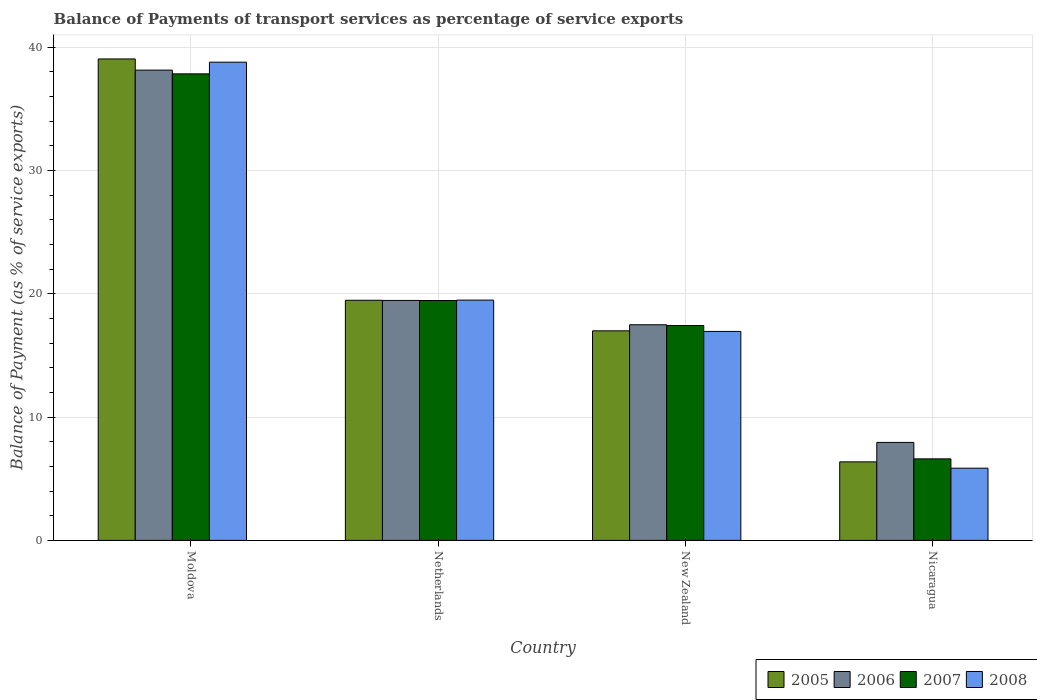How many groups of bars are there?
Your answer should be very brief. 4. Are the number of bars per tick equal to the number of legend labels?
Offer a very short reply. Yes. Are the number of bars on each tick of the X-axis equal?
Your answer should be compact. Yes. How many bars are there on the 4th tick from the left?
Offer a terse response. 4. What is the label of the 1st group of bars from the left?
Provide a short and direct response. Moldova. In how many cases, is the number of bars for a given country not equal to the number of legend labels?
Your answer should be very brief. 0. What is the balance of payments of transport services in 2008 in New Zealand?
Offer a terse response. 16.94. Across all countries, what is the maximum balance of payments of transport services in 2006?
Offer a very short reply. 38.13. Across all countries, what is the minimum balance of payments of transport services in 2008?
Make the answer very short. 5.85. In which country was the balance of payments of transport services in 2008 maximum?
Your answer should be compact. Moldova. In which country was the balance of payments of transport services in 2007 minimum?
Give a very brief answer. Nicaragua. What is the total balance of payments of transport services in 2007 in the graph?
Offer a terse response. 81.31. What is the difference between the balance of payments of transport services in 2006 in Moldova and that in Nicaragua?
Your answer should be compact. 30.19. What is the difference between the balance of payments of transport services in 2005 in New Zealand and the balance of payments of transport services in 2008 in Moldova?
Your answer should be compact. -21.78. What is the average balance of payments of transport services in 2007 per country?
Your answer should be compact. 20.33. What is the difference between the balance of payments of transport services of/in 2008 and balance of payments of transport services of/in 2006 in Nicaragua?
Provide a succinct answer. -2.09. In how many countries, is the balance of payments of transport services in 2005 greater than 20 %?
Offer a terse response. 1. What is the ratio of the balance of payments of transport services in 2006 in Netherlands to that in Nicaragua?
Provide a short and direct response. 2.45. Is the balance of payments of transport services in 2005 in Netherlands less than that in New Zealand?
Provide a short and direct response. No. Is the difference between the balance of payments of transport services in 2008 in Netherlands and New Zealand greater than the difference between the balance of payments of transport services in 2006 in Netherlands and New Zealand?
Offer a terse response. Yes. What is the difference between the highest and the second highest balance of payments of transport services in 2006?
Offer a very short reply. -1.97. What is the difference between the highest and the lowest balance of payments of transport services in 2008?
Keep it short and to the point. 32.92. In how many countries, is the balance of payments of transport services in 2007 greater than the average balance of payments of transport services in 2007 taken over all countries?
Your response must be concise. 1. Is it the case that in every country, the sum of the balance of payments of transport services in 2007 and balance of payments of transport services in 2005 is greater than the sum of balance of payments of transport services in 2006 and balance of payments of transport services in 2008?
Give a very brief answer. No. What does the 4th bar from the left in Netherlands represents?
Offer a very short reply. 2008. Is it the case that in every country, the sum of the balance of payments of transport services in 2008 and balance of payments of transport services in 2006 is greater than the balance of payments of transport services in 2007?
Give a very brief answer. Yes. How many countries are there in the graph?
Ensure brevity in your answer.  4. Are the values on the major ticks of Y-axis written in scientific E-notation?
Make the answer very short. No. Does the graph contain any zero values?
Ensure brevity in your answer.  No. How many legend labels are there?
Your answer should be compact. 4. How are the legend labels stacked?
Make the answer very short. Horizontal. What is the title of the graph?
Provide a short and direct response. Balance of Payments of transport services as percentage of service exports. Does "2001" appear as one of the legend labels in the graph?
Your answer should be compact. No. What is the label or title of the Y-axis?
Make the answer very short. Balance of Payment (as % of service exports). What is the Balance of Payment (as % of service exports) of 2005 in Moldova?
Offer a very short reply. 39.04. What is the Balance of Payment (as % of service exports) of 2006 in Moldova?
Give a very brief answer. 38.13. What is the Balance of Payment (as % of service exports) in 2007 in Moldova?
Offer a very short reply. 37.83. What is the Balance of Payment (as % of service exports) in 2008 in Moldova?
Keep it short and to the point. 38.78. What is the Balance of Payment (as % of service exports) of 2005 in Netherlands?
Your answer should be compact. 19.47. What is the Balance of Payment (as % of service exports) in 2006 in Netherlands?
Your answer should be compact. 19.46. What is the Balance of Payment (as % of service exports) in 2007 in Netherlands?
Provide a succinct answer. 19.45. What is the Balance of Payment (as % of service exports) in 2008 in Netherlands?
Keep it short and to the point. 19.48. What is the Balance of Payment (as % of service exports) of 2005 in New Zealand?
Provide a succinct answer. 16.99. What is the Balance of Payment (as % of service exports) in 2006 in New Zealand?
Make the answer very short. 17.48. What is the Balance of Payment (as % of service exports) in 2007 in New Zealand?
Offer a terse response. 17.42. What is the Balance of Payment (as % of service exports) of 2008 in New Zealand?
Make the answer very short. 16.94. What is the Balance of Payment (as % of service exports) in 2005 in Nicaragua?
Provide a short and direct response. 6.37. What is the Balance of Payment (as % of service exports) of 2006 in Nicaragua?
Your answer should be very brief. 7.95. What is the Balance of Payment (as % of service exports) in 2007 in Nicaragua?
Give a very brief answer. 6.61. What is the Balance of Payment (as % of service exports) of 2008 in Nicaragua?
Your answer should be very brief. 5.85. Across all countries, what is the maximum Balance of Payment (as % of service exports) of 2005?
Keep it short and to the point. 39.04. Across all countries, what is the maximum Balance of Payment (as % of service exports) of 2006?
Provide a succinct answer. 38.13. Across all countries, what is the maximum Balance of Payment (as % of service exports) of 2007?
Your answer should be very brief. 37.83. Across all countries, what is the maximum Balance of Payment (as % of service exports) of 2008?
Your answer should be very brief. 38.78. Across all countries, what is the minimum Balance of Payment (as % of service exports) of 2005?
Give a very brief answer. 6.37. Across all countries, what is the minimum Balance of Payment (as % of service exports) in 2006?
Provide a succinct answer. 7.95. Across all countries, what is the minimum Balance of Payment (as % of service exports) in 2007?
Provide a short and direct response. 6.61. Across all countries, what is the minimum Balance of Payment (as % of service exports) of 2008?
Keep it short and to the point. 5.85. What is the total Balance of Payment (as % of service exports) of 2005 in the graph?
Provide a succinct answer. 81.87. What is the total Balance of Payment (as % of service exports) in 2006 in the graph?
Give a very brief answer. 83.02. What is the total Balance of Payment (as % of service exports) of 2007 in the graph?
Your answer should be compact. 81.31. What is the total Balance of Payment (as % of service exports) in 2008 in the graph?
Give a very brief answer. 81.06. What is the difference between the Balance of Payment (as % of service exports) in 2005 in Moldova and that in Netherlands?
Offer a terse response. 19.57. What is the difference between the Balance of Payment (as % of service exports) of 2006 in Moldova and that in Netherlands?
Your answer should be compact. 18.67. What is the difference between the Balance of Payment (as % of service exports) in 2007 in Moldova and that in Netherlands?
Your response must be concise. 18.38. What is the difference between the Balance of Payment (as % of service exports) in 2008 in Moldova and that in Netherlands?
Offer a very short reply. 19.29. What is the difference between the Balance of Payment (as % of service exports) in 2005 in Moldova and that in New Zealand?
Your answer should be very brief. 22.05. What is the difference between the Balance of Payment (as % of service exports) in 2006 in Moldova and that in New Zealand?
Offer a very short reply. 20.65. What is the difference between the Balance of Payment (as % of service exports) of 2007 in Moldova and that in New Zealand?
Offer a terse response. 20.41. What is the difference between the Balance of Payment (as % of service exports) of 2008 in Moldova and that in New Zealand?
Your response must be concise. 21.83. What is the difference between the Balance of Payment (as % of service exports) of 2005 in Moldova and that in Nicaragua?
Make the answer very short. 32.67. What is the difference between the Balance of Payment (as % of service exports) of 2006 in Moldova and that in Nicaragua?
Your response must be concise. 30.19. What is the difference between the Balance of Payment (as % of service exports) of 2007 in Moldova and that in Nicaragua?
Provide a short and direct response. 31.22. What is the difference between the Balance of Payment (as % of service exports) of 2008 in Moldova and that in Nicaragua?
Provide a short and direct response. 32.92. What is the difference between the Balance of Payment (as % of service exports) of 2005 in Netherlands and that in New Zealand?
Keep it short and to the point. 2.48. What is the difference between the Balance of Payment (as % of service exports) of 2006 in Netherlands and that in New Zealand?
Keep it short and to the point. 1.97. What is the difference between the Balance of Payment (as % of service exports) of 2007 in Netherlands and that in New Zealand?
Offer a terse response. 2.03. What is the difference between the Balance of Payment (as % of service exports) in 2008 in Netherlands and that in New Zealand?
Make the answer very short. 2.54. What is the difference between the Balance of Payment (as % of service exports) in 2005 in Netherlands and that in Nicaragua?
Offer a very short reply. 13.1. What is the difference between the Balance of Payment (as % of service exports) of 2006 in Netherlands and that in Nicaragua?
Keep it short and to the point. 11.51. What is the difference between the Balance of Payment (as % of service exports) of 2007 in Netherlands and that in Nicaragua?
Offer a terse response. 12.84. What is the difference between the Balance of Payment (as % of service exports) of 2008 in Netherlands and that in Nicaragua?
Your response must be concise. 13.63. What is the difference between the Balance of Payment (as % of service exports) of 2005 in New Zealand and that in Nicaragua?
Your answer should be compact. 10.62. What is the difference between the Balance of Payment (as % of service exports) of 2006 in New Zealand and that in Nicaragua?
Make the answer very short. 9.54. What is the difference between the Balance of Payment (as % of service exports) of 2007 in New Zealand and that in Nicaragua?
Offer a terse response. 10.81. What is the difference between the Balance of Payment (as % of service exports) in 2008 in New Zealand and that in Nicaragua?
Offer a very short reply. 11.09. What is the difference between the Balance of Payment (as % of service exports) in 2005 in Moldova and the Balance of Payment (as % of service exports) in 2006 in Netherlands?
Give a very brief answer. 19.58. What is the difference between the Balance of Payment (as % of service exports) of 2005 in Moldova and the Balance of Payment (as % of service exports) of 2007 in Netherlands?
Provide a succinct answer. 19.59. What is the difference between the Balance of Payment (as % of service exports) of 2005 in Moldova and the Balance of Payment (as % of service exports) of 2008 in Netherlands?
Provide a short and direct response. 19.56. What is the difference between the Balance of Payment (as % of service exports) in 2006 in Moldova and the Balance of Payment (as % of service exports) in 2007 in Netherlands?
Your answer should be compact. 18.68. What is the difference between the Balance of Payment (as % of service exports) of 2006 in Moldova and the Balance of Payment (as % of service exports) of 2008 in Netherlands?
Keep it short and to the point. 18.65. What is the difference between the Balance of Payment (as % of service exports) of 2007 in Moldova and the Balance of Payment (as % of service exports) of 2008 in Netherlands?
Offer a terse response. 18.35. What is the difference between the Balance of Payment (as % of service exports) in 2005 in Moldova and the Balance of Payment (as % of service exports) in 2006 in New Zealand?
Your answer should be compact. 21.55. What is the difference between the Balance of Payment (as % of service exports) in 2005 in Moldova and the Balance of Payment (as % of service exports) in 2007 in New Zealand?
Your answer should be compact. 21.62. What is the difference between the Balance of Payment (as % of service exports) of 2005 in Moldova and the Balance of Payment (as % of service exports) of 2008 in New Zealand?
Your answer should be very brief. 22.09. What is the difference between the Balance of Payment (as % of service exports) of 2006 in Moldova and the Balance of Payment (as % of service exports) of 2007 in New Zealand?
Offer a very short reply. 20.71. What is the difference between the Balance of Payment (as % of service exports) of 2006 in Moldova and the Balance of Payment (as % of service exports) of 2008 in New Zealand?
Give a very brief answer. 21.19. What is the difference between the Balance of Payment (as % of service exports) of 2007 in Moldova and the Balance of Payment (as % of service exports) of 2008 in New Zealand?
Your response must be concise. 20.89. What is the difference between the Balance of Payment (as % of service exports) of 2005 in Moldova and the Balance of Payment (as % of service exports) of 2006 in Nicaragua?
Offer a terse response. 31.09. What is the difference between the Balance of Payment (as % of service exports) of 2005 in Moldova and the Balance of Payment (as % of service exports) of 2007 in Nicaragua?
Give a very brief answer. 32.43. What is the difference between the Balance of Payment (as % of service exports) of 2005 in Moldova and the Balance of Payment (as % of service exports) of 2008 in Nicaragua?
Provide a short and direct response. 33.18. What is the difference between the Balance of Payment (as % of service exports) in 2006 in Moldova and the Balance of Payment (as % of service exports) in 2007 in Nicaragua?
Give a very brief answer. 31.52. What is the difference between the Balance of Payment (as % of service exports) in 2006 in Moldova and the Balance of Payment (as % of service exports) in 2008 in Nicaragua?
Your answer should be compact. 32.28. What is the difference between the Balance of Payment (as % of service exports) of 2007 in Moldova and the Balance of Payment (as % of service exports) of 2008 in Nicaragua?
Keep it short and to the point. 31.98. What is the difference between the Balance of Payment (as % of service exports) of 2005 in Netherlands and the Balance of Payment (as % of service exports) of 2006 in New Zealand?
Keep it short and to the point. 1.99. What is the difference between the Balance of Payment (as % of service exports) of 2005 in Netherlands and the Balance of Payment (as % of service exports) of 2007 in New Zealand?
Provide a succinct answer. 2.05. What is the difference between the Balance of Payment (as % of service exports) of 2005 in Netherlands and the Balance of Payment (as % of service exports) of 2008 in New Zealand?
Ensure brevity in your answer.  2.53. What is the difference between the Balance of Payment (as % of service exports) in 2006 in Netherlands and the Balance of Payment (as % of service exports) in 2007 in New Zealand?
Make the answer very short. 2.04. What is the difference between the Balance of Payment (as % of service exports) of 2006 in Netherlands and the Balance of Payment (as % of service exports) of 2008 in New Zealand?
Provide a succinct answer. 2.51. What is the difference between the Balance of Payment (as % of service exports) of 2007 in Netherlands and the Balance of Payment (as % of service exports) of 2008 in New Zealand?
Your answer should be compact. 2.51. What is the difference between the Balance of Payment (as % of service exports) in 2005 in Netherlands and the Balance of Payment (as % of service exports) in 2006 in Nicaragua?
Offer a terse response. 11.52. What is the difference between the Balance of Payment (as % of service exports) in 2005 in Netherlands and the Balance of Payment (as % of service exports) in 2007 in Nicaragua?
Offer a terse response. 12.86. What is the difference between the Balance of Payment (as % of service exports) in 2005 in Netherlands and the Balance of Payment (as % of service exports) in 2008 in Nicaragua?
Give a very brief answer. 13.62. What is the difference between the Balance of Payment (as % of service exports) in 2006 in Netherlands and the Balance of Payment (as % of service exports) in 2007 in Nicaragua?
Make the answer very short. 12.85. What is the difference between the Balance of Payment (as % of service exports) in 2006 in Netherlands and the Balance of Payment (as % of service exports) in 2008 in Nicaragua?
Keep it short and to the point. 13.6. What is the difference between the Balance of Payment (as % of service exports) in 2007 in Netherlands and the Balance of Payment (as % of service exports) in 2008 in Nicaragua?
Offer a terse response. 13.6. What is the difference between the Balance of Payment (as % of service exports) in 2005 in New Zealand and the Balance of Payment (as % of service exports) in 2006 in Nicaragua?
Your answer should be very brief. 9.05. What is the difference between the Balance of Payment (as % of service exports) in 2005 in New Zealand and the Balance of Payment (as % of service exports) in 2007 in Nicaragua?
Make the answer very short. 10.38. What is the difference between the Balance of Payment (as % of service exports) in 2005 in New Zealand and the Balance of Payment (as % of service exports) in 2008 in Nicaragua?
Make the answer very short. 11.14. What is the difference between the Balance of Payment (as % of service exports) of 2006 in New Zealand and the Balance of Payment (as % of service exports) of 2007 in Nicaragua?
Ensure brevity in your answer.  10.87. What is the difference between the Balance of Payment (as % of service exports) in 2006 in New Zealand and the Balance of Payment (as % of service exports) in 2008 in Nicaragua?
Ensure brevity in your answer.  11.63. What is the difference between the Balance of Payment (as % of service exports) of 2007 in New Zealand and the Balance of Payment (as % of service exports) of 2008 in Nicaragua?
Make the answer very short. 11.57. What is the average Balance of Payment (as % of service exports) of 2005 per country?
Your answer should be compact. 20.47. What is the average Balance of Payment (as % of service exports) in 2006 per country?
Provide a short and direct response. 20.76. What is the average Balance of Payment (as % of service exports) of 2007 per country?
Give a very brief answer. 20.33. What is the average Balance of Payment (as % of service exports) in 2008 per country?
Provide a succinct answer. 20.26. What is the difference between the Balance of Payment (as % of service exports) in 2005 and Balance of Payment (as % of service exports) in 2006 in Moldova?
Make the answer very short. 0.91. What is the difference between the Balance of Payment (as % of service exports) in 2005 and Balance of Payment (as % of service exports) in 2007 in Moldova?
Keep it short and to the point. 1.21. What is the difference between the Balance of Payment (as % of service exports) of 2005 and Balance of Payment (as % of service exports) of 2008 in Moldova?
Your answer should be compact. 0.26. What is the difference between the Balance of Payment (as % of service exports) of 2006 and Balance of Payment (as % of service exports) of 2007 in Moldova?
Provide a short and direct response. 0.3. What is the difference between the Balance of Payment (as % of service exports) of 2006 and Balance of Payment (as % of service exports) of 2008 in Moldova?
Keep it short and to the point. -0.64. What is the difference between the Balance of Payment (as % of service exports) in 2007 and Balance of Payment (as % of service exports) in 2008 in Moldova?
Keep it short and to the point. -0.95. What is the difference between the Balance of Payment (as % of service exports) of 2005 and Balance of Payment (as % of service exports) of 2006 in Netherlands?
Your answer should be very brief. 0.01. What is the difference between the Balance of Payment (as % of service exports) of 2005 and Balance of Payment (as % of service exports) of 2007 in Netherlands?
Your response must be concise. 0.02. What is the difference between the Balance of Payment (as % of service exports) in 2005 and Balance of Payment (as % of service exports) in 2008 in Netherlands?
Your answer should be very brief. -0.01. What is the difference between the Balance of Payment (as % of service exports) in 2006 and Balance of Payment (as % of service exports) in 2007 in Netherlands?
Keep it short and to the point. 0.01. What is the difference between the Balance of Payment (as % of service exports) in 2006 and Balance of Payment (as % of service exports) in 2008 in Netherlands?
Give a very brief answer. -0.03. What is the difference between the Balance of Payment (as % of service exports) in 2007 and Balance of Payment (as % of service exports) in 2008 in Netherlands?
Give a very brief answer. -0.03. What is the difference between the Balance of Payment (as % of service exports) in 2005 and Balance of Payment (as % of service exports) in 2006 in New Zealand?
Your response must be concise. -0.49. What is the difference between the Balance of Payment (as % of service exports) of 2005 and Balance of Payment (as % of service exports) of 2007 in New Zealand?
Keep it short and to the point. -0.43. What is the difference between the Balance of Payment (as % of service exports) in 2005 and Balance of Payment (as % of service exports) in 2008 in New Zealand?
Give a very brief answer. 0.05. What is the difference between the Balance of Payment (as % of service exports) of 2006 and Balance of Payment (as % of service exports) of 2007 in New Zealand?
Offer a terse response. 0.06. What is the difference between the Balance of Payment (as % of service exports) of 2006 and Balance of Payment (as % of service exports) of 2008 in New Zealand?
Keep it short and to the point. 0.54. What is the difference between the Balance of Payment (as % of service exports) of 2007 and Balance of Payment (as % of service exports) of 2008 in New Zealand?
Make the answer very short. 0.48. What is the difference between the Balance of Payment (as % of service exports) of 2005 and Balance of Payment (as % of service exports) of 2006 in Nicaragua?
Keep it short and to the point. -1.58. What is the difference between the Balance of Payment (as % of service exports) in 2005 and Balance of Payment (as % of service exports) in 2007 in Nicaragua?
Ensure brevity in your answer.  -0.24. What is the difference between the Balance of Payment (as % of service exports) in 2005 and Balance of Payment (as % of service exports) in 2008 in Nicaragua?
Offer a terse response. 0.51. What is the difference between the Balance of Payment (as % of service exports) in 2006 and Balance of Payment (as % of service exports) in 2007 in Nicaragua?
Provide a succinct answer. 1.33. What is the difference between the Balance of Payment (as % of service exports) in 2006 and Balance of Payment (as % of service exports) in 2008 in Nicaragua?
Keep it short and to the point. 2.09. What is the difference between the Balance of Payment (as % of service exports) of 2007 and Balance of Payment (as % of service exports) of 2008 in Nicaragua?
Provide a succinct answer. 0.76. What is the ratio of the Balance of Payment (as % of service exports) of 2005 in Moldova to that in Netherlands?
Provide a succinct answer. 2.01. What is the ratio of the Balance of Payment (as % of service exports) in 2006 in Moldova to that in Netherlands?
Your answer should be very brief. 1.96. What is the ratio of the Balance of Payment (as % of service exports) in 2007 in Moldova to that in Netherlands?
Your answer should be very brief. 1.94. What is the ratio of the Balance of Payment (as % of service exports) in 2008 in Moldova to that in Netherlands?
Your response must be concise. 1.99. What is the ratio of the Balance of Payment (as % of service exports) of 2005 in Moldova to that in New Zealand?
Give a very brief answer. 2.3. What is the ratio of the Balance of Payment (as % of service exports) in 2006 in Moldova to that in New Zealand?
Keep it short and to the point. 2.18. What is the ratio of the Balance of Payment (as % of service exports) of 2007 in Moldova to that in New Zealand?
Keep it short and to the point. 2.17. What is the ratio of the Balance of Payment (as % of service exports) in 2008 in Moldova to that in New Zealand?
Your answer should be compact. 2.29. What is the ratio of the Balance of Payment (as % of service exports) in 2005 in Moldova to that in Nicaragua?
Make the answer very short. 6.13. What is the ratio of the Balance of Payment (as % of service exports) in 2006 in Moldova to that in Nicaragua?
Your answer should be very brief. 4.8. What is the ratio of the Balance of Payment (as % of service exports) in 2007 in Moldova to that in Nicaragua?
Make the answer very short. 5.72. What is the ratio of the Balance of Payment (as % of service exports) of 2008 in Moldova to that in Nicaragua?
Offer a terse response. 6.62. What is the ratio of the Balance of Payment (as % of service exports) in 2005 in Netherlands to that in New Zealand?
Give a very brief answer. 1.15. What is the ratio of the Balance of Payment (as % of service exports) of 2006 in Netherlands to that in New Zealand?
Offer a terse response. 1.11. What is the ratio of the Balance of Payment (as % of service exports) in 2007 in Netherlands to that in New Zealand?
Give a very brief answer. 1.12. What is the ratio of the Balance of Payment (as % of service exports) of 2008 in Netherlands to that in New Zealand?
Offer a terse response. 1.15. What is the ratio of the Balance of Payment (as % of service exports) of 2005 in Netherlands to that in Nicaragua?
Provide a succinct answer. 3.06. What is the ratio of the Balance of Payment (as % of service exports) in 2006 in Netherlands to that in Nicaragua?
Provide a succinct answer. 2.45. What is the ratio of the Balance of Payment (as % of service exports) in 2007 in Netherlands to that in Nicaragua?
Ensure brevity in your answer.  2.94. What is the ratio of the Balance of Payment (as % of service exports) in 2008 in Netherlands to that in Nicaragua?
Offer a very short reply. 3.33. What is the ratio of the Balance of Payment (as % of service exports) in 2005 in New Zealand to that in Nicaragua?
Ensure brevity in your answer.  2.67. What is the ratio of the Balance of Payment (as % of service exports) of 2006 in New Zealand to that in Nicaragua?
Your response must be concise. 2.2. What is the ratio of the Balance of Payment (as % of service exports) of 2007 in New Zealand to that in Nicaragua?
Your answer should be very brief. 2.64. What is the ratio of the Balance of Payment (as % of service exports) of 2008 in New Zealand to that in Nicaragua?
Your answer should be compact. 2.89. What is the difference between the highest and the second highest Balance of Payment (as % of service exports) of 2005?
Your answer should be compact. 19.57. What is the difference between the highest and the second highest Balance of Payment (as % of service exports) in 2006?
Give a very brief answer. 18.67. What is the difference between the highest and the second highest Balance of Payment (as % of service exports) in 2007?
Your response must be concise. 18.38. What is the difference between the highest and the second highest Balance of Payment (as % of service exports) of 2008?
Ensure brevity in your answer.  19.29. What is the difference between the highest and the lowest Balance of Payment (as % of service exports) in 2005?
Keep it short and to the point. 32.67. What is the difference between the highest and the lowest Balance of Payment (as % of service exports) of 2006?
Offer a very short reply. 30.19. What is the difference between the highest and the lowest Balance of Payment (as % of service exports) of 2007?
Provide a short and direct response. 31.22. What is the difference between the highest and the lowest Balance of Payment (as % of service exports) of 2008?
Offer a very short reply. 32.92. 